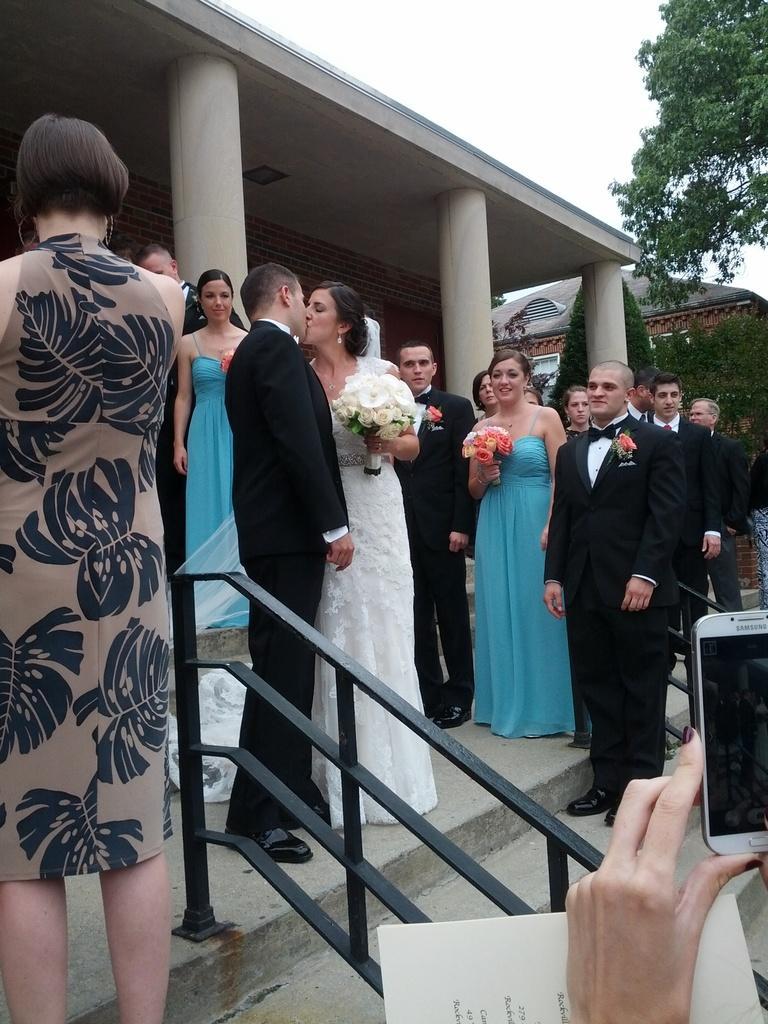In one or two sentences, can you explain what this image depicts? In this image I can see group of people standing. Among them two women are holding the bouquet with white and orange flowers. There is a person holding the mobile and the paper. Few people are wearing the blazers. In the back there is a building,trees,and a sky. 